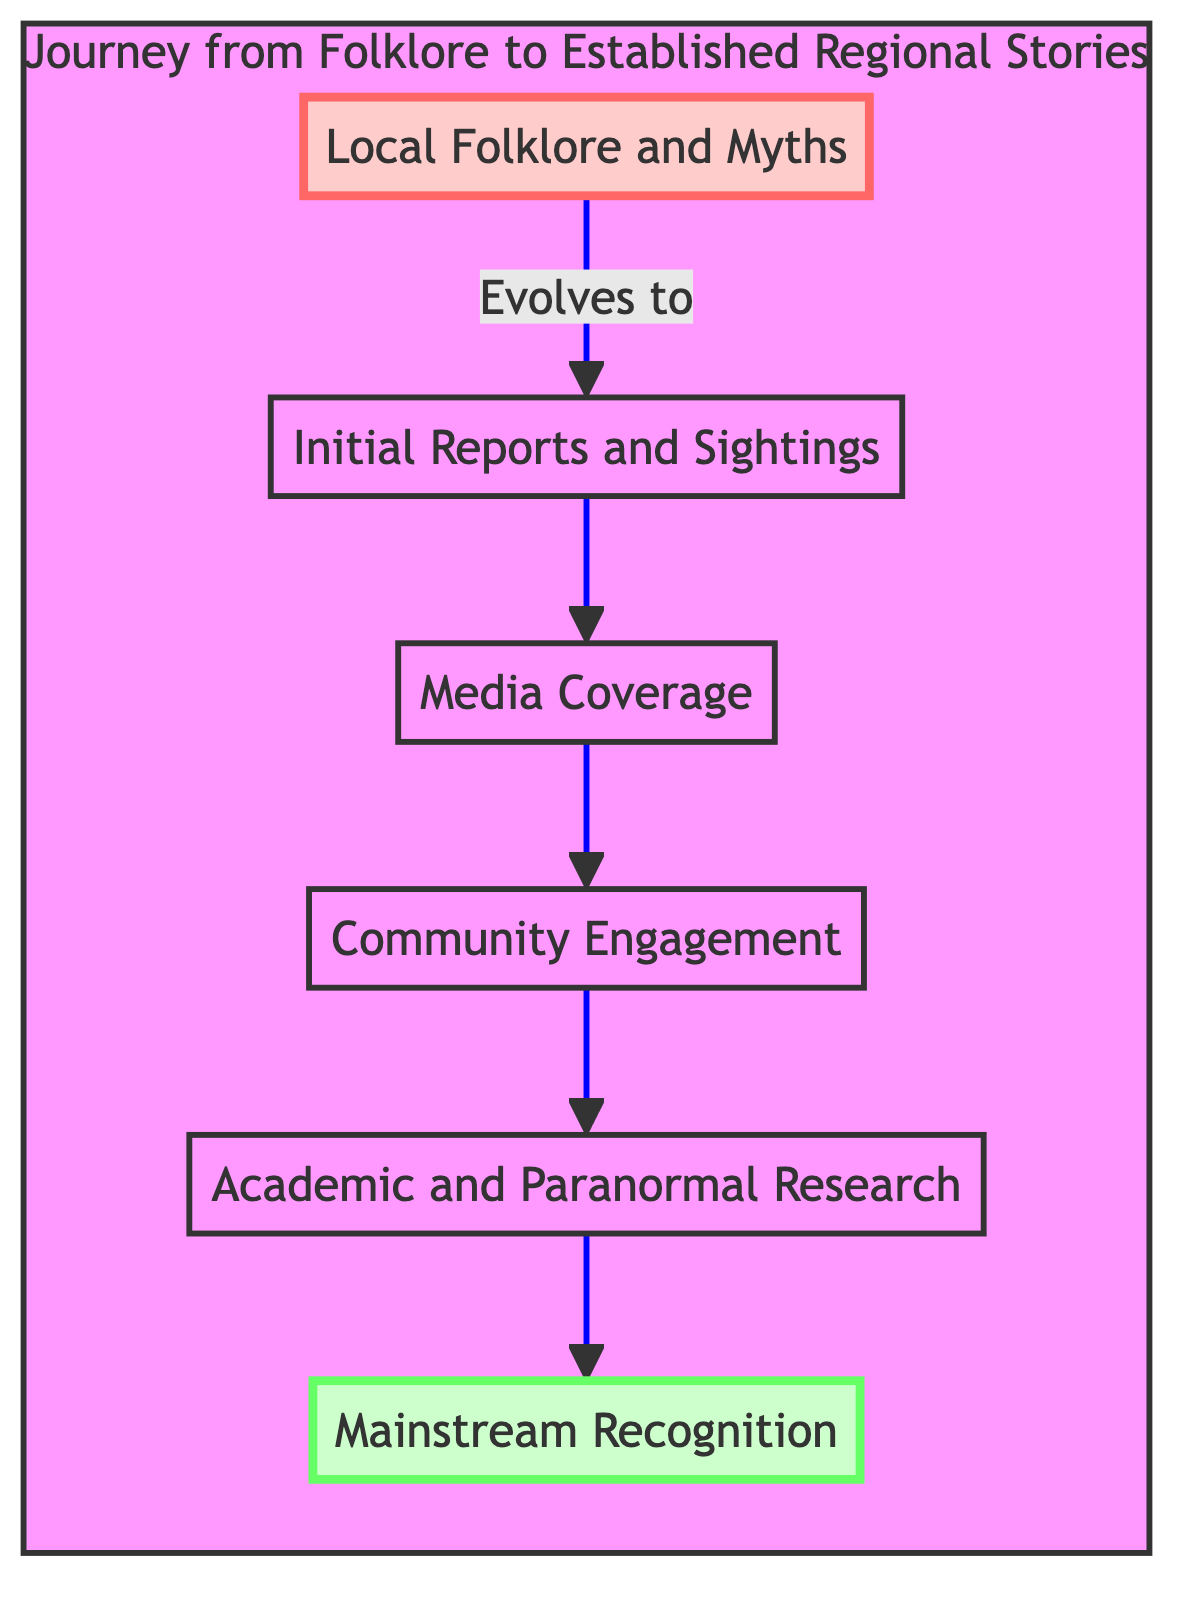What is the title of the first level in the diagram? The diagram begins with the first level titled "Local Folklore and Myths," which is indicated at the bottom of the flowchart.
Answer: Local Folklore and Myths How many levels are represented in the diagram? The diagram features a total of six levels, counting from "Local Folklore and Myths" at the bottom to "Mainstream Recognition" at the top.
Answer: Six What evolves to "Initial Reports and Sightings"? The arrow points from the node "Local Folklore and Myths" to "Initial Reports and Sightings," indicating that it is the direct predecessor in the flow of the diagram.
Answer: Local Folklore and Myths What does "Media Coverage" lead to in the flowchart? The "Media Coverage" node is followed by the "Community Engagement" node, illustrating that media influences community involvement in the folklore narratives.
Answer: Community Engagement Which level is associated with "Academic and Paranormal Research"? The node titled "Academic and Paranormal Research" is positioned at level five in the flowchart, right before "Mainstream Recognition," indicating its role as a precursor to broader acceptance.
Answer: Level 5 What is the connection between "Community Engagement" and "Mainstream Recognition"? "Community Engagement" leads to "Academic and Paranormal Research," which in turn connects to "Mainstream Recognition," showing that community involvement can advance the folklore's prominence to a recognized cultural aspect.
Answer: E to F What is the final stage in the journey depicted in the diagram? The topmost level of the flowchart signifies the final stage, which is "Mainstream Recognition," indicating the culmination of the journey from folklore to widely accepted narratives.
Answer: Mainstream Recognition What type of events are represented by "Community Engagement"? The "Community Engagement" node encompasses local discussions, folklore festivals, and storytelling sessions, highlighting the participatory aspect of folklore in a community setting.
Answer: Folklore festivals What example is given for "Initial Reports and Sightings"? The flowchart cites UFO sightings in Roswell, New Mexico as a notable example of "Initial Reports and Sightings," conveying how such events initiate the folklore journey.
Answer: UFO sightings in Roswell, New Mexico 